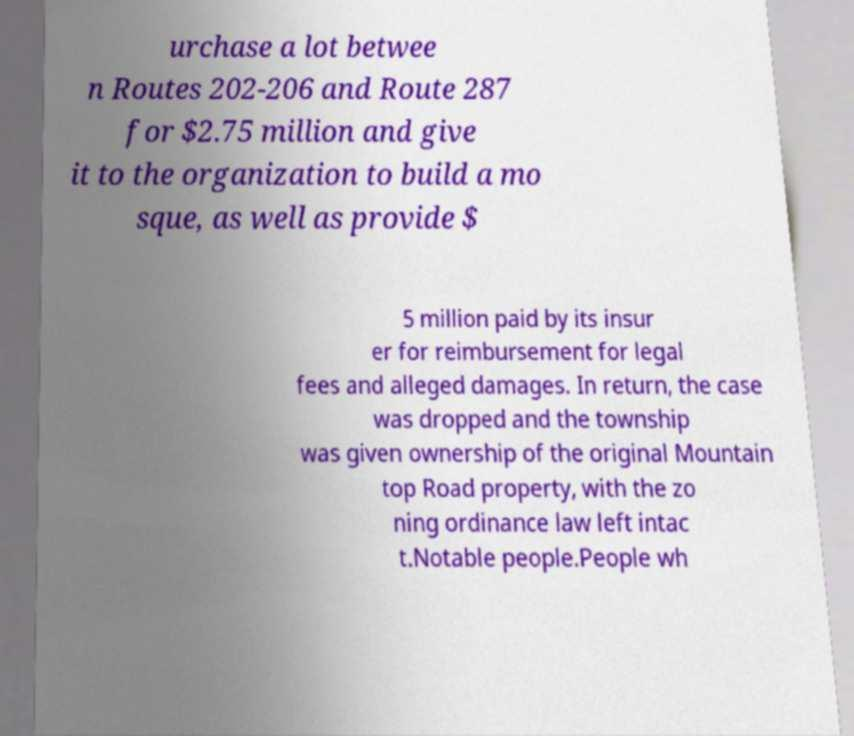Can you read and provide the text displayed in the image?This photo seems to have some interesting text. Can you extract and type it out for me? urchase a lot betwee n Routes 202-206 and Route 287 for $2.75 million and give it to the organization to build a mo sque, as well as provide $ 5 million paid by its insur er for reimbursement for legal fees and alleged damages. In return, the case was dropped and the township was given ownership of the original Mountain top Road property, with the zo ning ordinance law left intac t.Notable people.People wh 